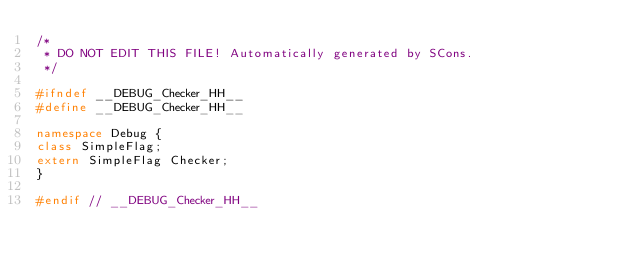<code> <loc_0><loc_0><loc_500><loc_500><_C++_>/*
 * DO NOT EDIT THIS FILE! Automatically generated by SCons.
 */

#ifndef __DEBUG_Checker_HH__
#define __DEBUG_Checker_HH__

namespace Debug {
class SimpleFlag;
extern SimpleFlag Checker;
}

#endif // __DEBUG_Checker_HH__
</code> 